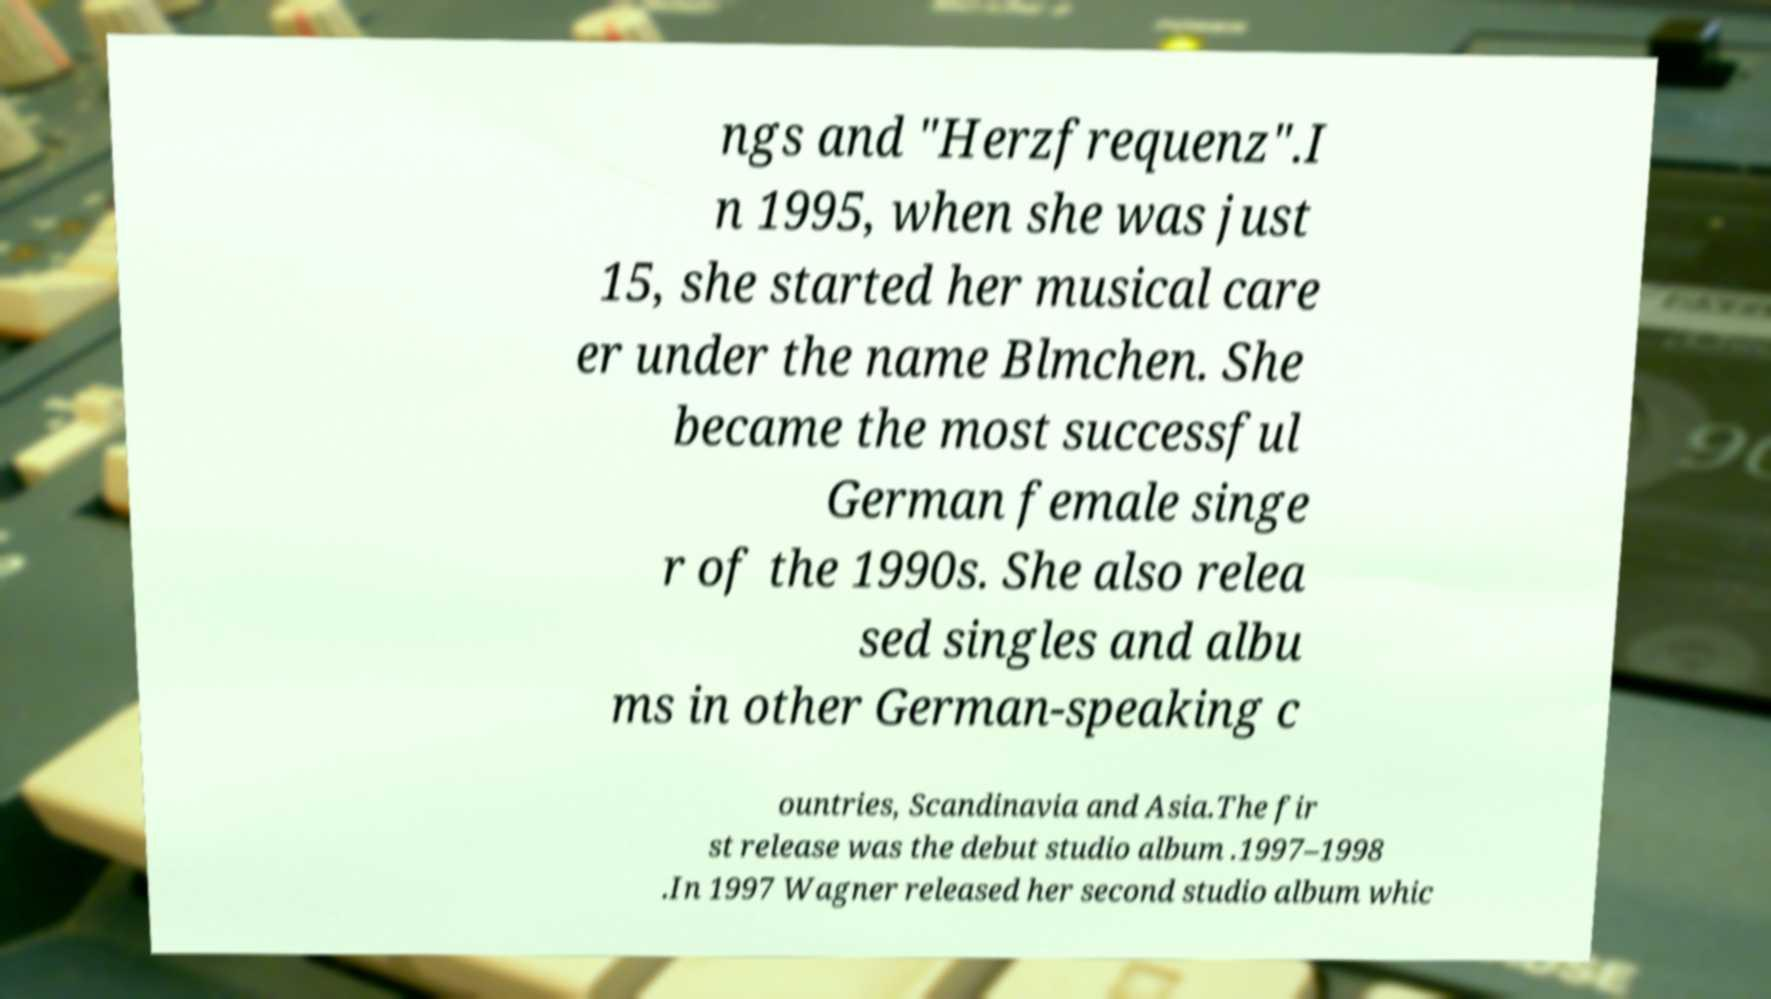I need the written content from this picture converted into text. Can you do that? ngs and "Herzfrequenz".I n 1995, when she was just 15, she started her musical care er under the name Blmchen. She became the most successful German female singe r of the 1990s. She also relea sed singles and albu ms in other German-speaking c ountries, Scandinavia and Asia.The fir st release was the debut studio album .1997–1998 .In 1997 Wagner released her second studio album whic 